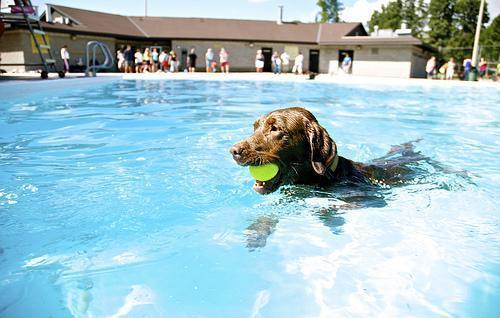How many dogs at the pool?
Give a very brief answer. 1. 